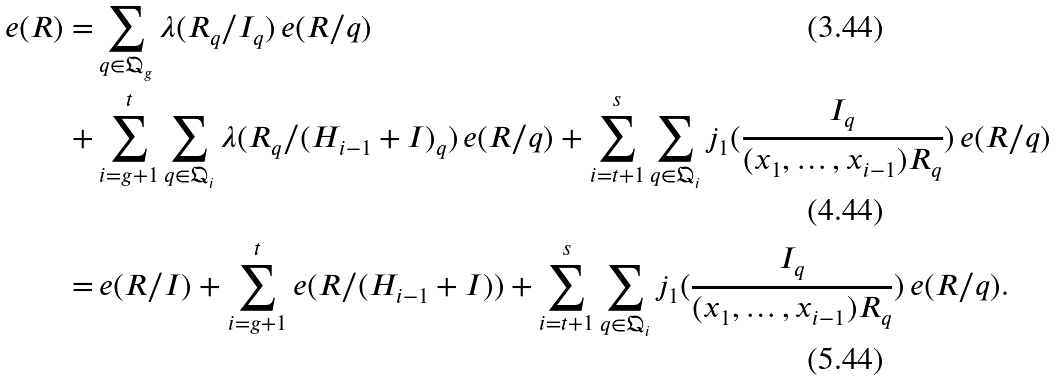<formula> <loc_0><loc_0><loc_500><loc_500>e ( R ) = & \sum _ { q \in \mathfrak { Q } _ { g } } \lambda ( R _ { q } / I _ { q } ) \, e ( R / q ) \\ + & \sum _ { i = g + 1 } ^ { t } \sum _ { q \in \mathfrak { Q } _ { i } } \lambda ( R _ { q } / ( H _ { i - 1 } + I ) _ { q } ) \, e ( R / q ) + \sum _ { i = t + 1 } ^ { s } \sum _ { q \in \mathfrak { Q } _ { i } } j _ { 1 } ( \frac { I _ { q } } { ( x _ { 1 } , \dots , x _ { i - 1 } ) R _ { q } } ) \, e ( R / q ) \\ = & \, e ( R / I ) + \sum _ { i = g + 1 } ^ { t } e ( R / ( H _ { i - 1 } + I ) ) + \sum _ { i = t + 1 } ^ { s } \sum _ { q \in \mathfrak { Q } _ { i } } j _ { 1 } ( \frac { I _ { q } } { ( x _ { 1 } , \dots , x _ { i - 1 } ) R _ { q } } ) \, e ( R / q ) .</formula> 